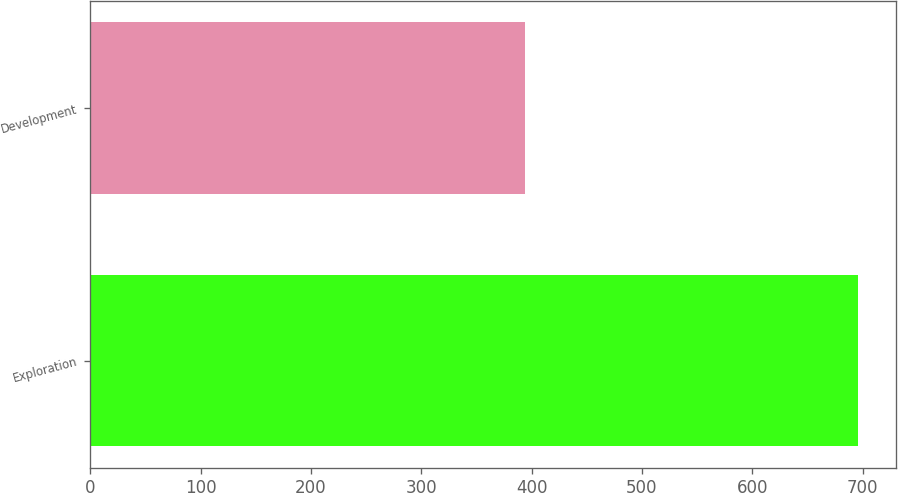Convert chart to OTSL. <chart><loc_0><loc_0><loc_500><loc_500><bar_chart><fcel>Exploration<fcel>Development<nl><fcel>696<fcel>394<nl></chart> 